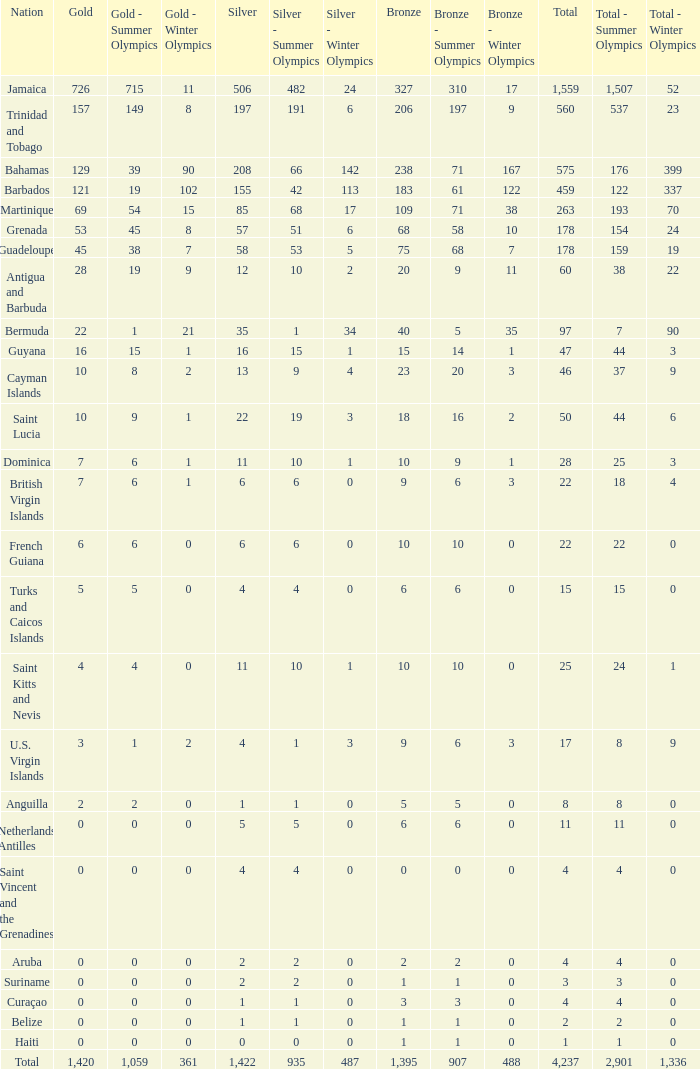What's the sum of Gold with a Bronze that's larger than 15, Silver that's smaller than 197, the Nation of Saint Lucia, and has a Total that is larger than 50? None. 